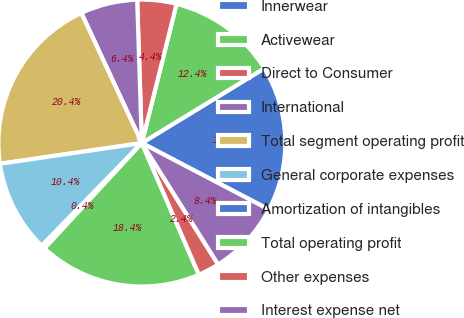Convert chart. <chart><loc_0><loc_0><loc_500><loc_500><pie_chart><fcel>Innerwear<fcel>Activewear<fcel>Direct to Consumer<fcel>International<fcel>Total segment operating profit<fcel>General corporate expenses<fcel>Amortization of intangibles<fcel>Total operating profit<fcel>Other expenses<fcel>Interest expense net<nl><fcel>16.39%<fcel>12.39%<fcel>4.41%<fcel>6.41%<fcel>20.38%<fcel>10.4%<fcel>0.42%<fcel>18.38%<fcel>2.42%<fcel>8.4%<nl></chart> 